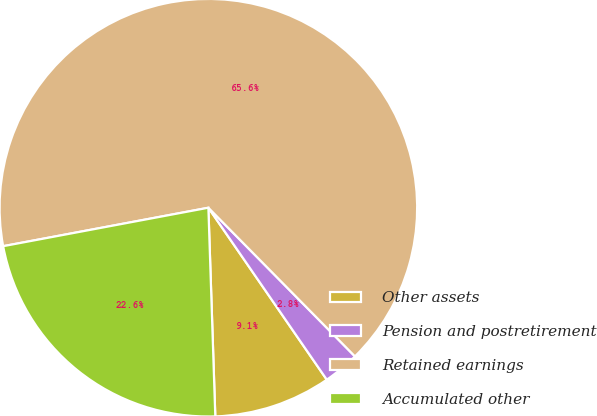<chart> <loc_0><loc_0><loc_500><loc_500><pie_chart><fcel>Other assets<fcel>Pension and postretirement<fcel>Retained earnings<fcel>Accumulated other<nl><fcel>9.07%<fcel>2.79%<fcel>65.56%<fcel>22.58%<nl></chart> 